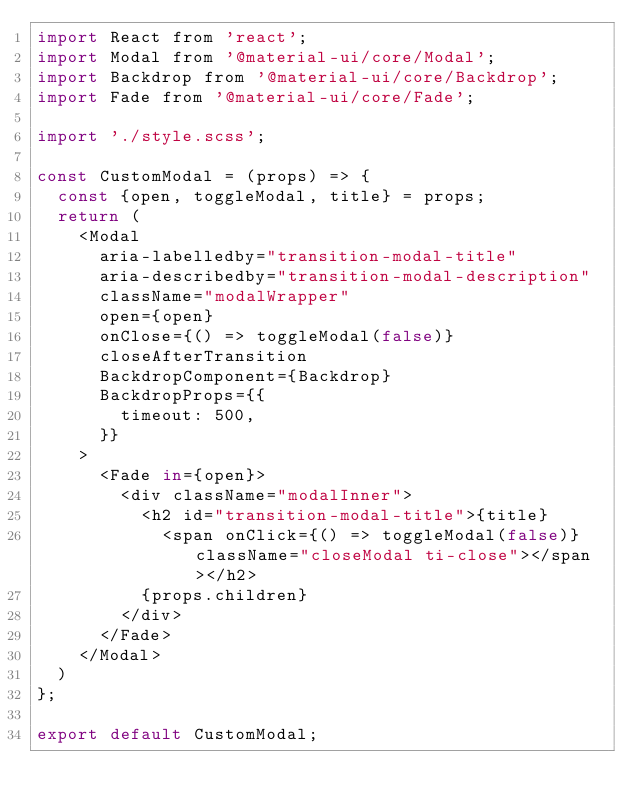<code> <loc_0><loc_0><loc_500><loc_500><_JavaScript_>import React from 'react';
import Modal from '@material-ui/core/Modal';
import Backdrop from '@material-ui/core/Backdrop';
import Fade from '@material-ui/core/Fade';

import './style.scss';

const CustomModal = (props) => {
  const {open, toggleModal, title} = props;
  return (
    <Modal
      aria-labelledby="transition-modal-title"
      aria-describedby="transition-modal-description"
      className="modalWrapper"
      open={open}
      onClose={() => toggleModal(false)}
      closeAfterTransition
      BackdropComponent={Backdrop}
      BackdropProps={{
        timeout: 500,
      }}
    >
      <Fade in={open}>
        <div className="modalInner">
          <h2 id="transition-modal-title">{title}
            <span onClick={() => toggleModal(false)} className="closeModal ti-close"></span></h2>
          {props.children}
        </div>
      </Fade>
    </Modal>
  )
};

export default CustomModal;
</code> 